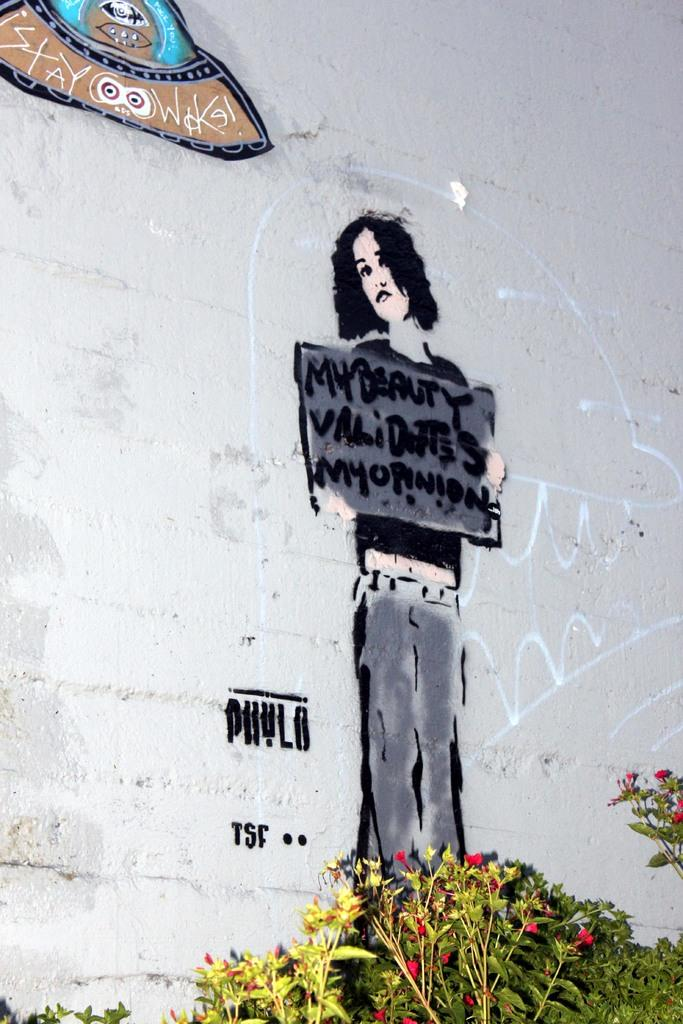What is the main subject of the painting in the image? The main subject of the painting in the image is a girl. What is the girl holding in the painting? The girl is holding a banner in the painting. What other element is depicted in the painting? There is a UFO depicted in the painting. Where is the painting located in the image? The painting is on a wall. What can be seen in the front of the image? There is a flower plant in the front of the image. What type of nation is depicted in the painting? There is no nation depicted in the painting; it features a girl, a banner, and a UFO. What kind of stone is present in the image? There is no stone present in the image; it features a painting of a girl, a banner, a UFO, a wall, and a flower plant. 